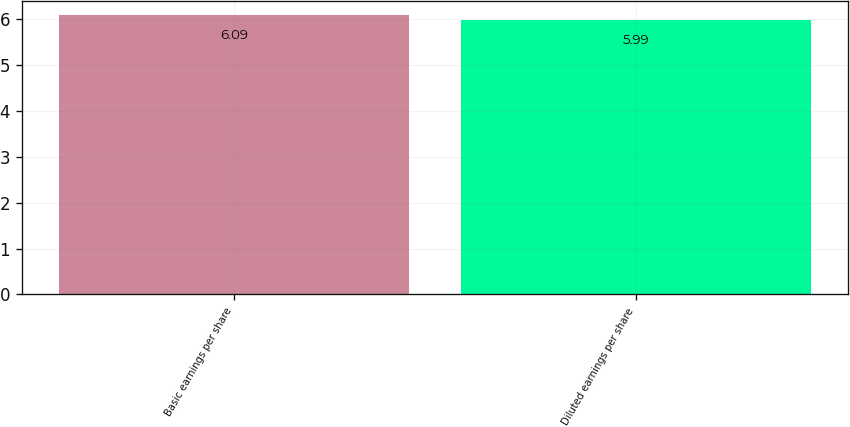Convert chart. <chart><loc_0><loc_0><loc_500><loc_500><bar_chart><fcel>Basic earnings per share<fcel>Diluted earnings per share<nl><fcel>6.09<fcel>5.99<nl></chart> 